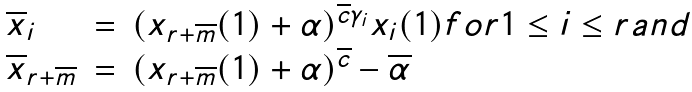Convert formula to latex. <formula><loc_0><loc_0><loc_500><loc_500>\begin{array} { l l l } \overline { x } _ { i } & = & ( x _ { r + \overline { m } } ( 1 ) + \alpha ) ^ { \overline { c } \gamma _ { i } } x _ { i } ( 1 ) f o r 1 \leq i \leq r a n d \\ \overline { x } _ { r + \overline { m } } & = & ( x _ { r + \overline { m } } ( 1 ) + \alpha ) ^ { \overline { c } } - \overline { \alpha } \end{array}</formula> 